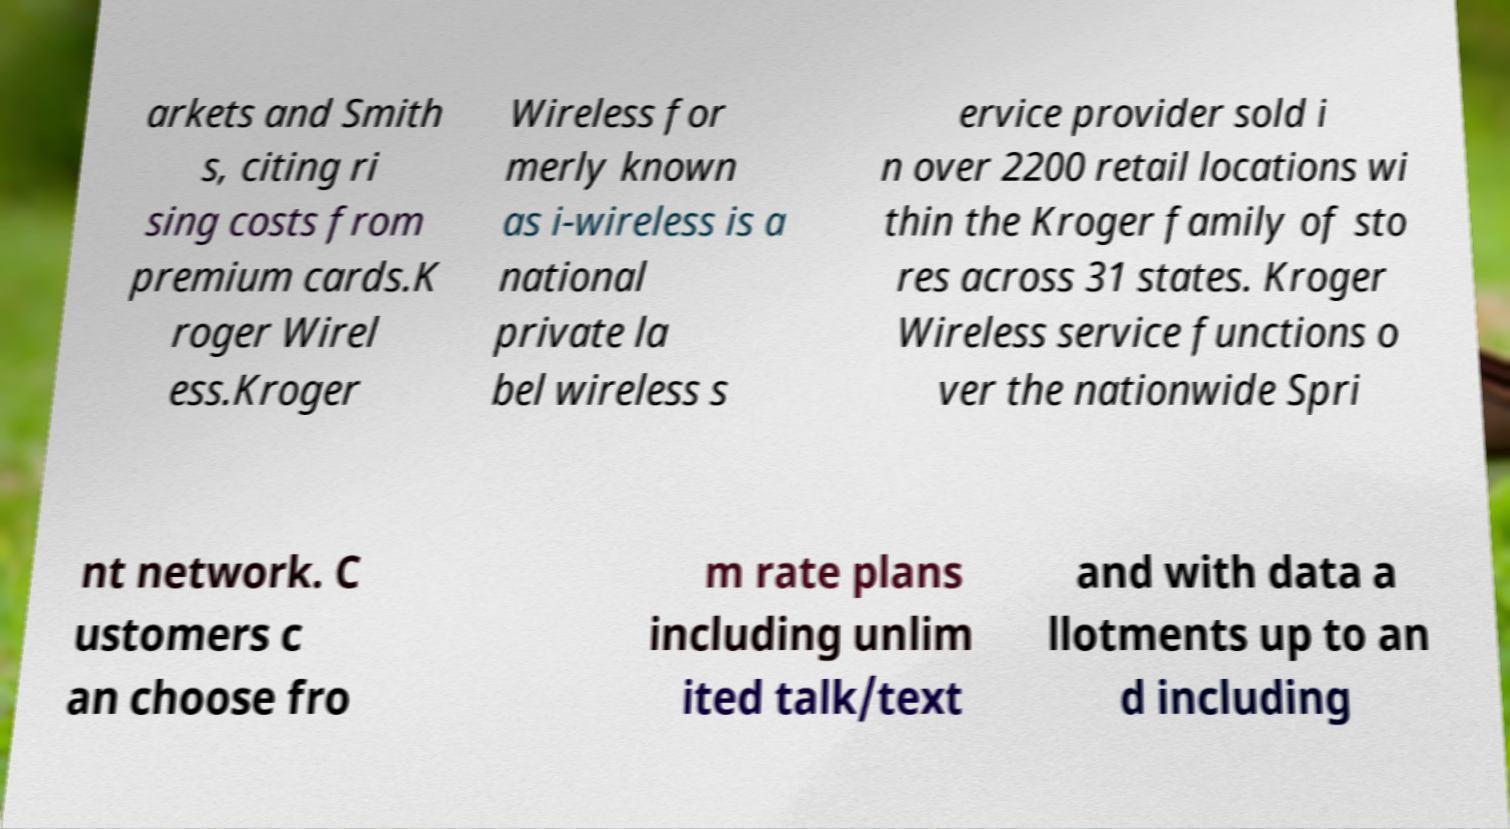For documentation purposes, I need the text within this image transcribed. Could you provide that? arkets and Smith s, citing ri sing costs from premium cards.K roger Wirel ess.Kroger Wireless for merly known as i-wireless is a national private la bel wireless s ervice provider sold i n over 2200 retail locations wi thin the Kroger family of sto res across 31 states. Kroger Wireless service functions o ver the nationwide Spri nt network. C ustomers c an choose fro m rate plans including unlim ited talk/text and with data a llotments up to an d including 